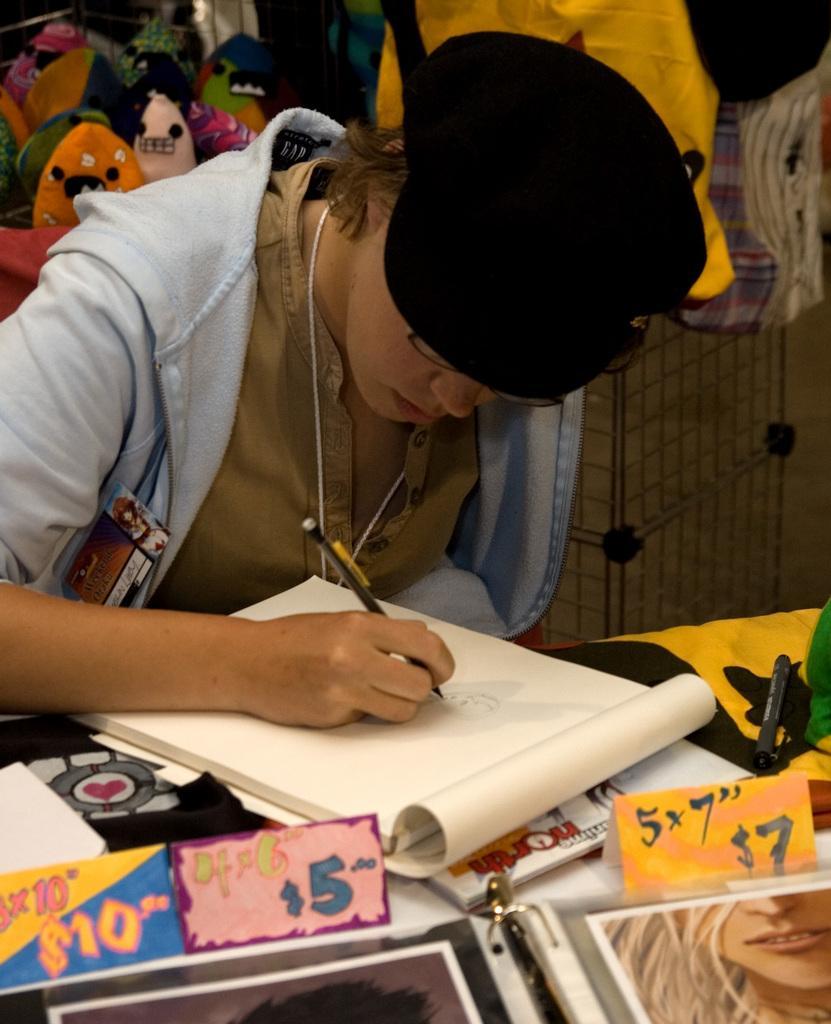Could you give a brief overview of what you see in this image? In the picture we can see people sitting in the chair near the table on it, we can see a book and something kept at it and a person is writing something in the book with a pen and in the background also we can see some things are placed. 